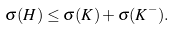<formula> <loc_0><loc_0><loc_500><loc_500>\label l { e q \colon b o u n d } \sigma ( H ) \leq \sigma ( K ) + \sigma ( K ^ { - } ) .</formula> 